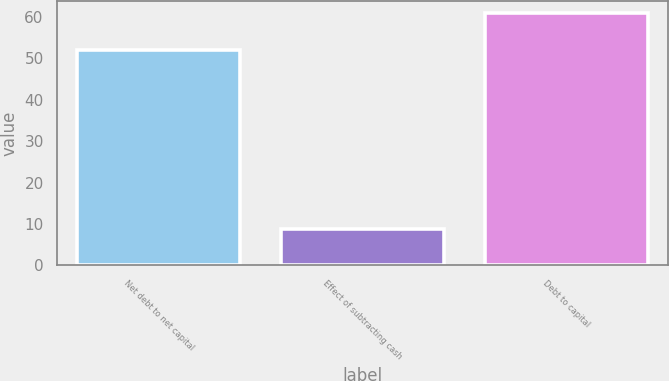<chart> <loc_0><loc_0><loc_500><loc_500><bar_chart><fcel>Net debt to net capital<fcel>Effect of subtracting cash<fcel>Debt to capital<nl><fcel>52<fcel>8.9<fcel>60.9<nl></chart> 